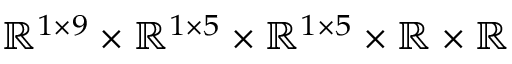Convert formula to latex. <formula><loc_0><loc_0><loc_500><loc_500>\mathbb { R } ^ { 1 \times 9 } \times \mathbb { R } ^ { 1 \times 5 } \times \mathbb { R } ^ { 1 \times 5 } \times \mathbb { R } \times \mathbb { R }</formula> 